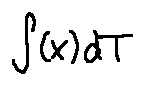<formula> <loc_0><loc_0><loc_500><loc_500>\int ( x ) d T</formula> 